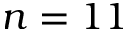Convert formula to latex. <formula><loc_0><loc_0><loc_500><loc_500>n = 1 1</formula> 